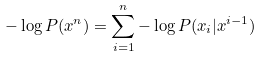<formula> <loc_0><loc_0><loc_500><loc_500>- \log P ( x ^ { n } ) = \sum _ { i = 1 } ^ { n } - \log P ( x _ { i } | x ^ { i - 1 } )</formula> 